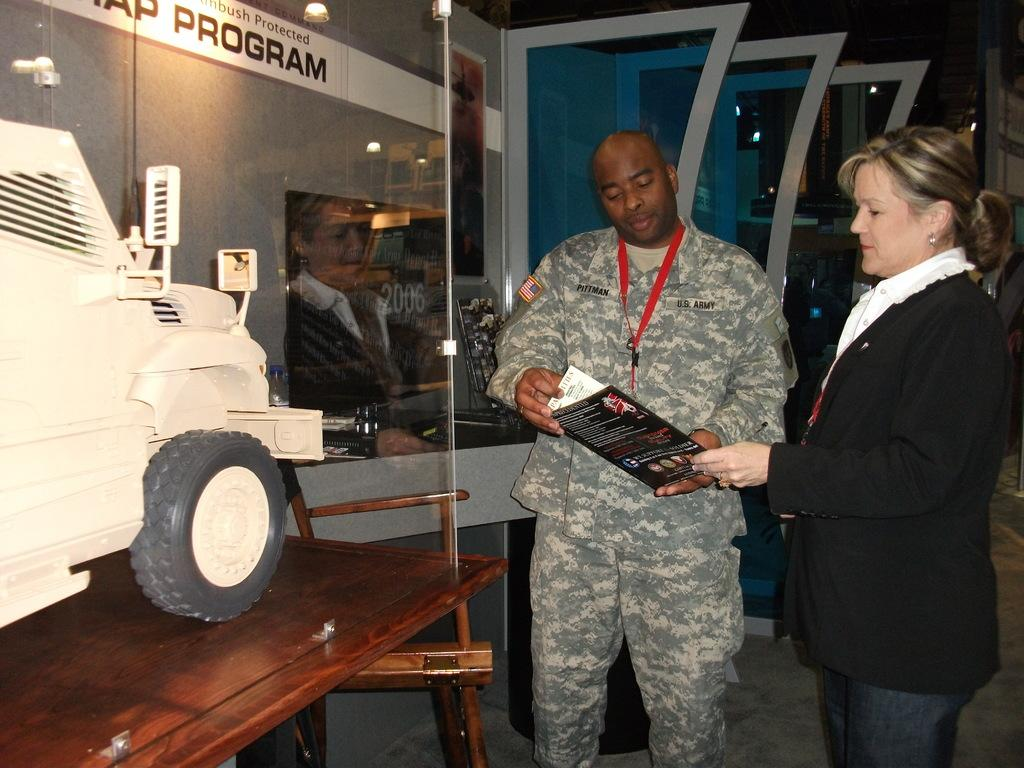How many people are in the image? There are two people in the image, a man and a woman. What are the man and woman doing in the image? The man and woman are standing and holding a book. What object can be seen on a table in the image? There is a show car on a table in the image. Where is the wound on the man's body in the image? There is no wound present on the man's body in the image. What decision is the woman making in the image? There is no indication of a decision being made by the woman in the image. 